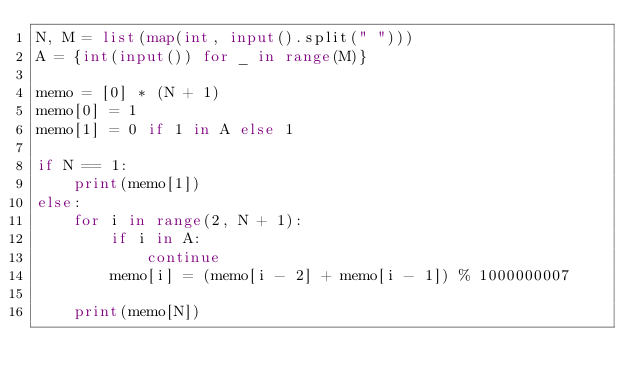<code> <loc_0><loc_0><loc_500><loc_500><_Python_>N, M = list(map(int, input().split(" ")))
A = {int(input()) for _ in range(M)}

memo = [0] * (N + 1)
memo[0] = 1
memo[1] = 0 if 1 in A else 1

if N == 1:
    print(memo[1])
else:
    for i in range(2, N + 1):
        if i in A:
            continue
        memo[i] = (memo[i - 2] + memo[i - 1]) % 1000000007

    print(memo[N])
</code> 